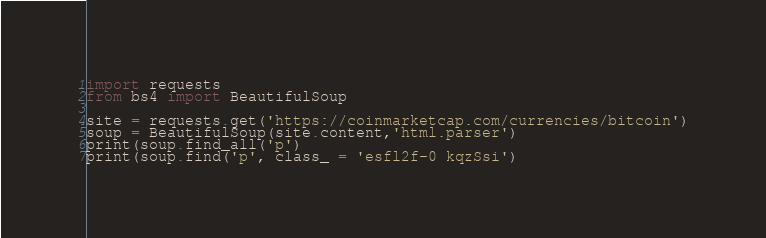Convert code to text. <code><loc_0><loc_0><loc_500><loc_500><_Python_>import requests
from bs4 import BeautifulSoup

site = requests.get('https://coinmarketcap.com/currencies/bitcoin')
soup = BeautifulSoup(site.content,'html.parser')
print(soup.find_all('p')
print(soup.find('p', class_ = 'esfl2f-0 kqzSsi')
</code> 